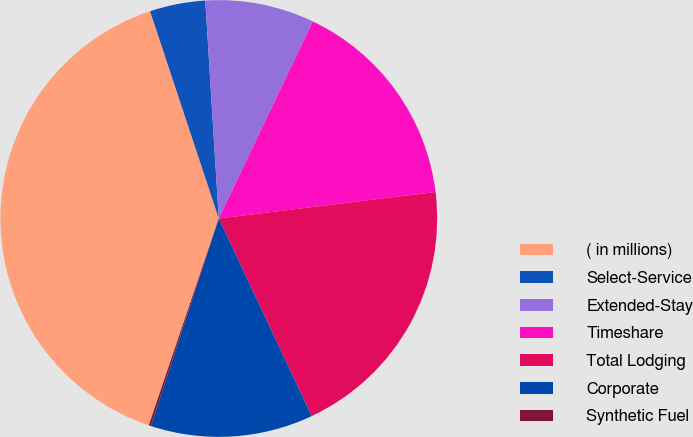Convert chart. <chart><loc_0><loc_0><loc_500><loc_500><pie_chart><fcel>( in millions)<fcel>Select-Service<fcel>Extended-Stay<fcel>Timeshare<fcel>Total Lodging<fcel>Corporate<fcel>Synthetic Fuel<nl><fcel>39.71%<fcel>4.11%<fcel>8.07%<fcel>15.98%<fcel>19.94%<fcel>12.03%<fcel>0.16%<nl></chart> 